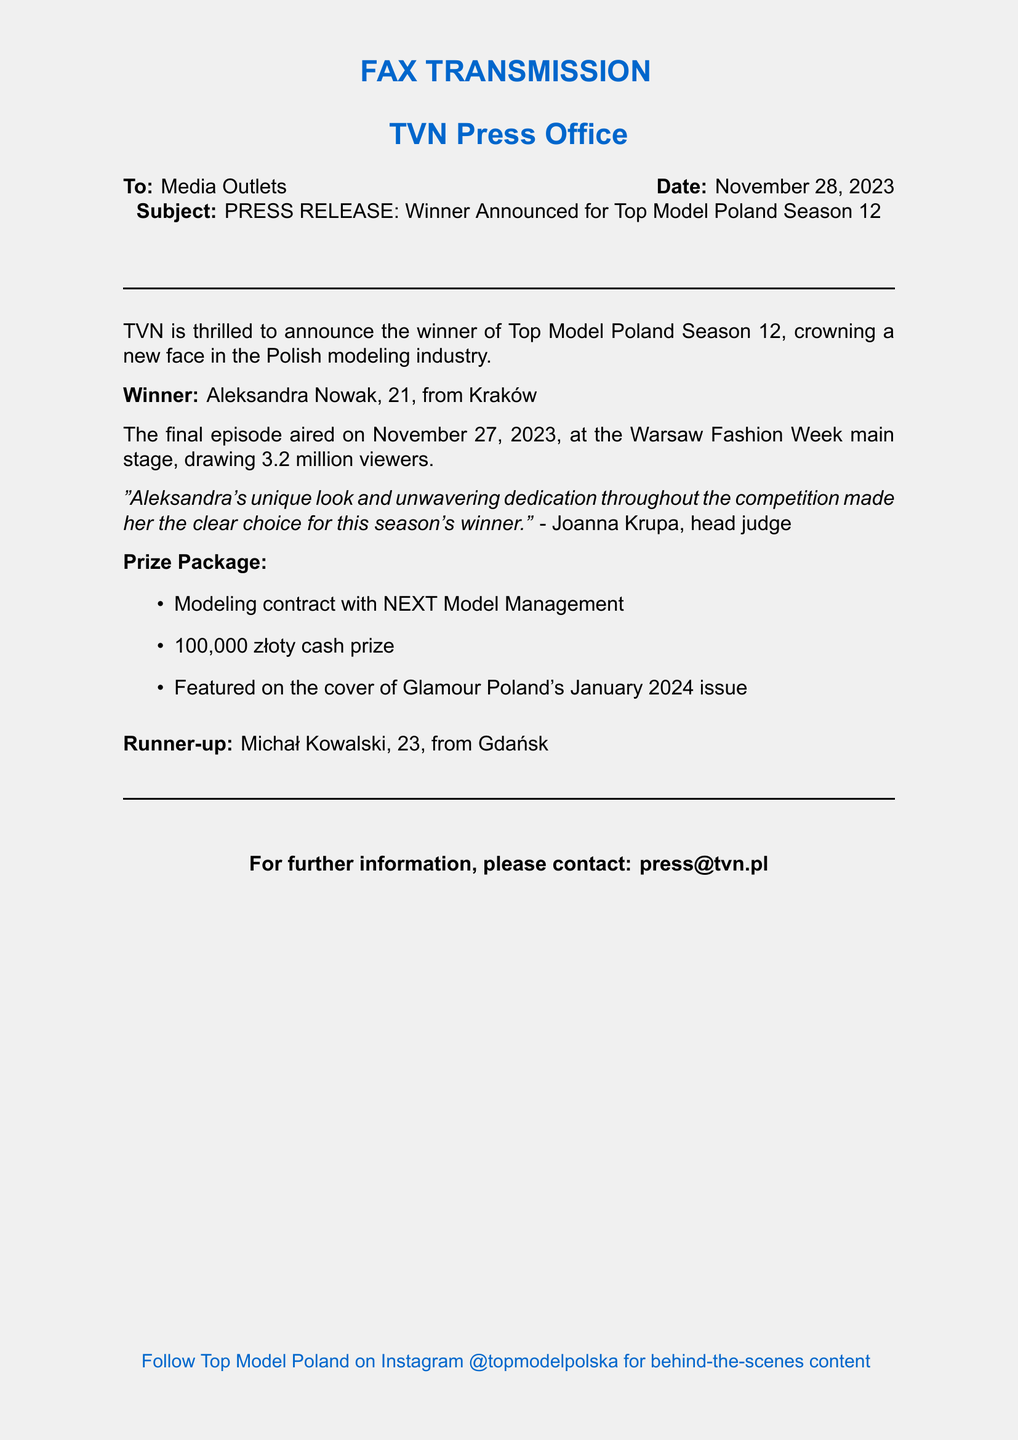What is the name of the winner? The winner of Top Model Poland Season 12 is mentioned in the document.
Answer: Aleksandra Nowak How old is the winner? The age of the winner is explicitly provided in the document.
Answer: 21 What date did the final episode air? The document specifies the date of the final episode's airing.
Answer: November 27, 2023 How many viewers watched the final episode? The viewer count for the final episode is stated in the document.
Answer: 3.2 million Who is the runner-up? The document includes the name of the runner-up in the competition.
Answer: Michał Kowalski What is the cash prize amount? The cash prize is clearly listed in the document.
Answer: 100,000 złoty What modeling agency will the winner sign with? The document mentions the modeling agency associated with the winner's contract.
Answer: NEXT Model Management What does Joanna Krupa say about the winner? The quote provided in the document reflects the head judge’s opinion about the winner.
Answer: "Aleksandra's unique look and unwavering dedication throughout the competition made her the clear choice for this season's winner." What issue of Glamour Poland will feature the winner? The magazine that will feature the winner is specified with an exact date.
Answer: January 2024 issue 